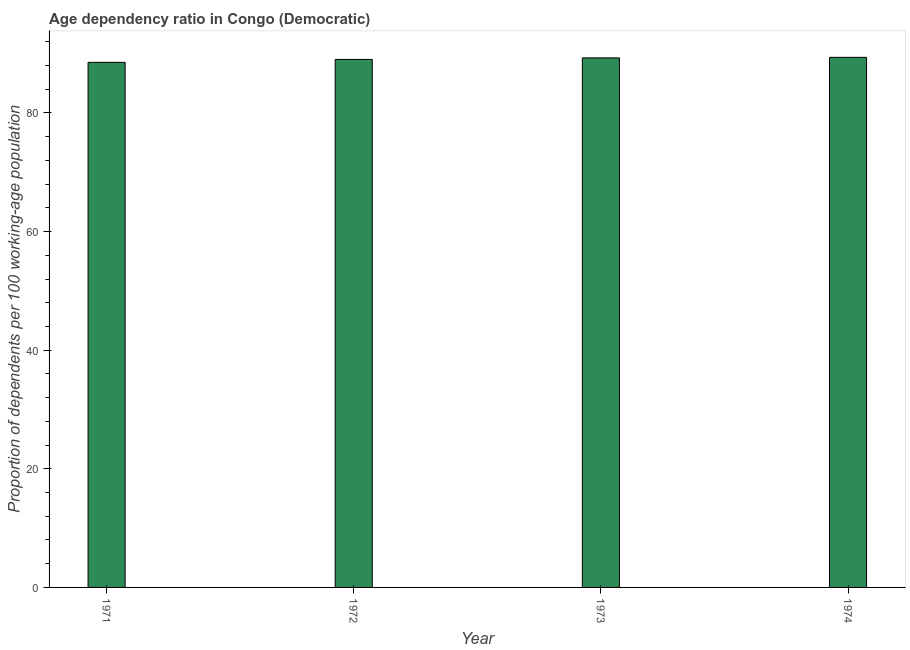Does the graph contain any zero values?
Offer a very short reply. No. Does the graph contain grids?
Ensure brevity in your answer.  No. What is the title of the graph?
Ensure brevity in your answer.  Age dependency ratio in Congo (Democratic). What is the label or title of the Y-axis?
Offer a terse response. Proportion of dependents per 100 working-age population. What is the age dependency ratio in 1974?
Keep it short and to the point. 89.38. Across all years, what is the maximum age dependency ratio?
Offer a very short reply. 89.38. Across all years, what is the minimum age dependency ratio?
Give a very brief answer. 88.54. In which year was the age dependency ratio maximum?
Ensure brevity in your answer.  1974. What is the sum of the age dependency ratio?
Provide a short and direct response. 356.24. What is the difference between the age dependency ratio in 1971 and 1972?
Make the answer very short. -0.49. What is the average age dependency ratio per year?
Your answer should be compact. 89.06. What is the median age dependency ratio?
Make the answer very short. 89.16. Do a majority of the years between 1973 and 1971 (inclusive) have age dependency ratio greater than 80 ?
Give a very brief answer. Yes. What is the ratio of the age dependency ratio in 1971 to that in 1972?
Your answer should be compact. 0.99. Is the difference between the age dependency ratio in 1971 and 1973 greater than the difference between any two years?
Provide a short and direct response. No. What is the difference between the highest and the second highest age dependency ratio?
Your answer should be very brief. 0.09. Is the sum of the age dependency ratio in 1972 and 1974 greater than the maximum age dependency ratio across all years?
Give a very brief answer. Yes. In how many years, is the age dependency ratio greater than the average age dependency ratio taken over all years?
Provide a succinct answer. 2. What is the difference between two consecutive major ticks on the Y-axis?
Your answer should be very brief. 20. What is the Proportion of dependents per 100 working-age population in 1971?
Make the answer very short. 88.54. What is the Proportion of dependents per 100 working-age population of 1972?
Make the answer very short. 89.03. What is the Proportion of dependents per 100 working-age population of 1973?
Give a very brief answer. 89.29. What is the Proportion of dependents per 100 working-age population of 1974?
Provide a succinct answer. 89.38. What is the difference between the Proportion of dependents per 100 working-age population in 1971 and 1972?
Give a very brief answer. -0.49. What is the difference between the Proportion of dependents per 100 working-age population in 1971 and 1973?
Offer a very short reply. -0.75. What is the difference between the Proportion of dependents per 100 working-age population in 1971 and 1974?
Offer a terse response. -0.85. What is the difference between the Proportion of dependents per 100 working-age population in 1972 and 1973?
Ensure brevity in your answer.  -0.26. What is the difference between the Proportion of dependents per 100 working-age population in 1972 and 1974?
Offer a very short reply. -0.35. What is the difference between the Proportion of dependents per 100 working-age population in 1973 and 1974?
Keep it short and to the point. -0.09. What is the ratio of the Proportion of dependents per 100 working-age population in 1971 to that in 1973?
Make the answer very short. 0.99. What is the ratio of the Proportion of dependents per 100 working-age population in 1971 to that in 1974?
Your answer should be very brief. 0.99. What is the ratio of the Proportion of dependents per 100 working-age population in 1973 to that in 1974?
Offer a very short reply. 1. 